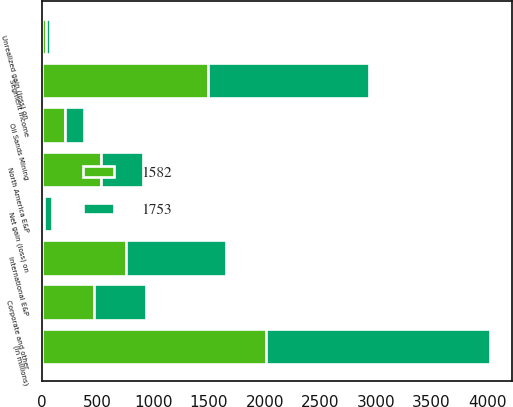Convert chart to OTSL. <chart><loc_0><loc_0><loc_500><loc_500><stacked_bar_chart><ecel><fcel>(In millions)<fcel>North America E&P<fcel>International E&P<fcel>Oil Sands Mining<fcel>Segment income<fcel>Corporate and other<fcel>Unrealized gain (loss) on<fcel>Net gain (loss) on<nl><fcel>1582<fcel>2013<fcel>529<fcel>758<fcel>206<fcel>1493<fcel>470<fcel>33<fcel>20<nl><fcel>1753<fcel>2012<fcel>382<fcel>895<fcel>171<fcel>1448<fcel>467<fcel>34<fcel>72<nl></chart> 